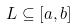<formula> <loc_0><loc_0><loc_500><loc_500>L \subseteq [ a , b ]</formula> 